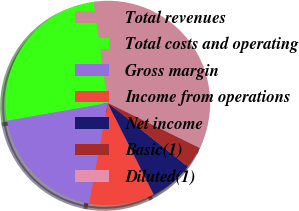Convert chart to OTSL. <chart><loc_0><loc_0><loc_500><loc_500><pie_chart><fcel>Total revenues<fcel>Total costs and operating<fcel>Gross margin<fcel>Income from operations<fcel>Net income<fcel>Basic(1)<fcel>Diluted(1)<nl><fcel>34.47%<fcel>25.55%<fcel>19.3%<fcel>10.34%<fcel>6.89%<fcel>3.45%<fcel>0.0%<nl></chart> 